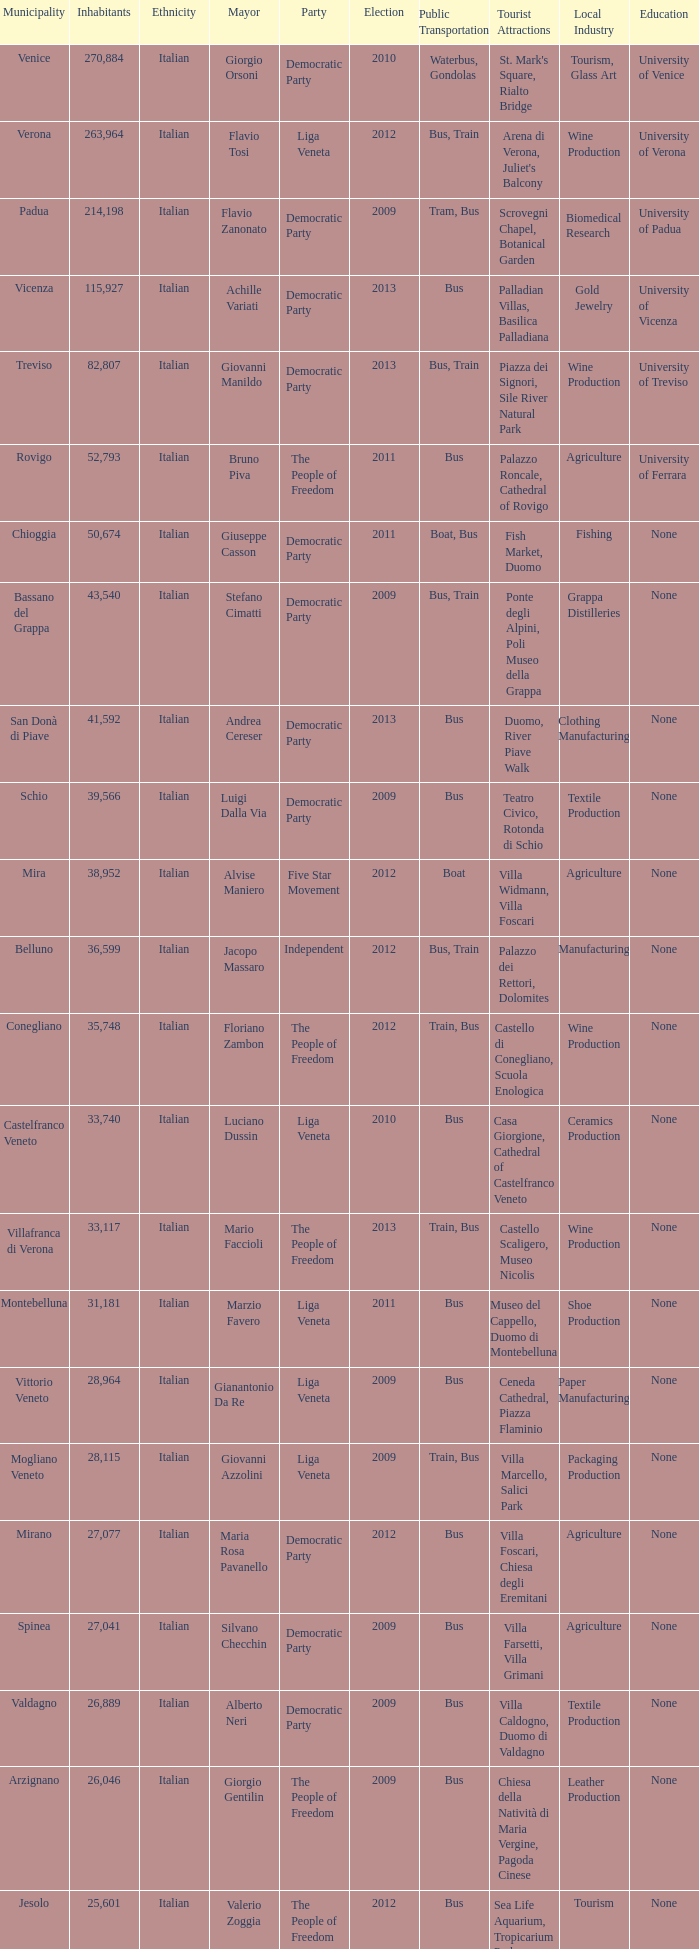How many elections had more than 36,599 inhabitants when Mayor was giovanni manildo? 1.0. 